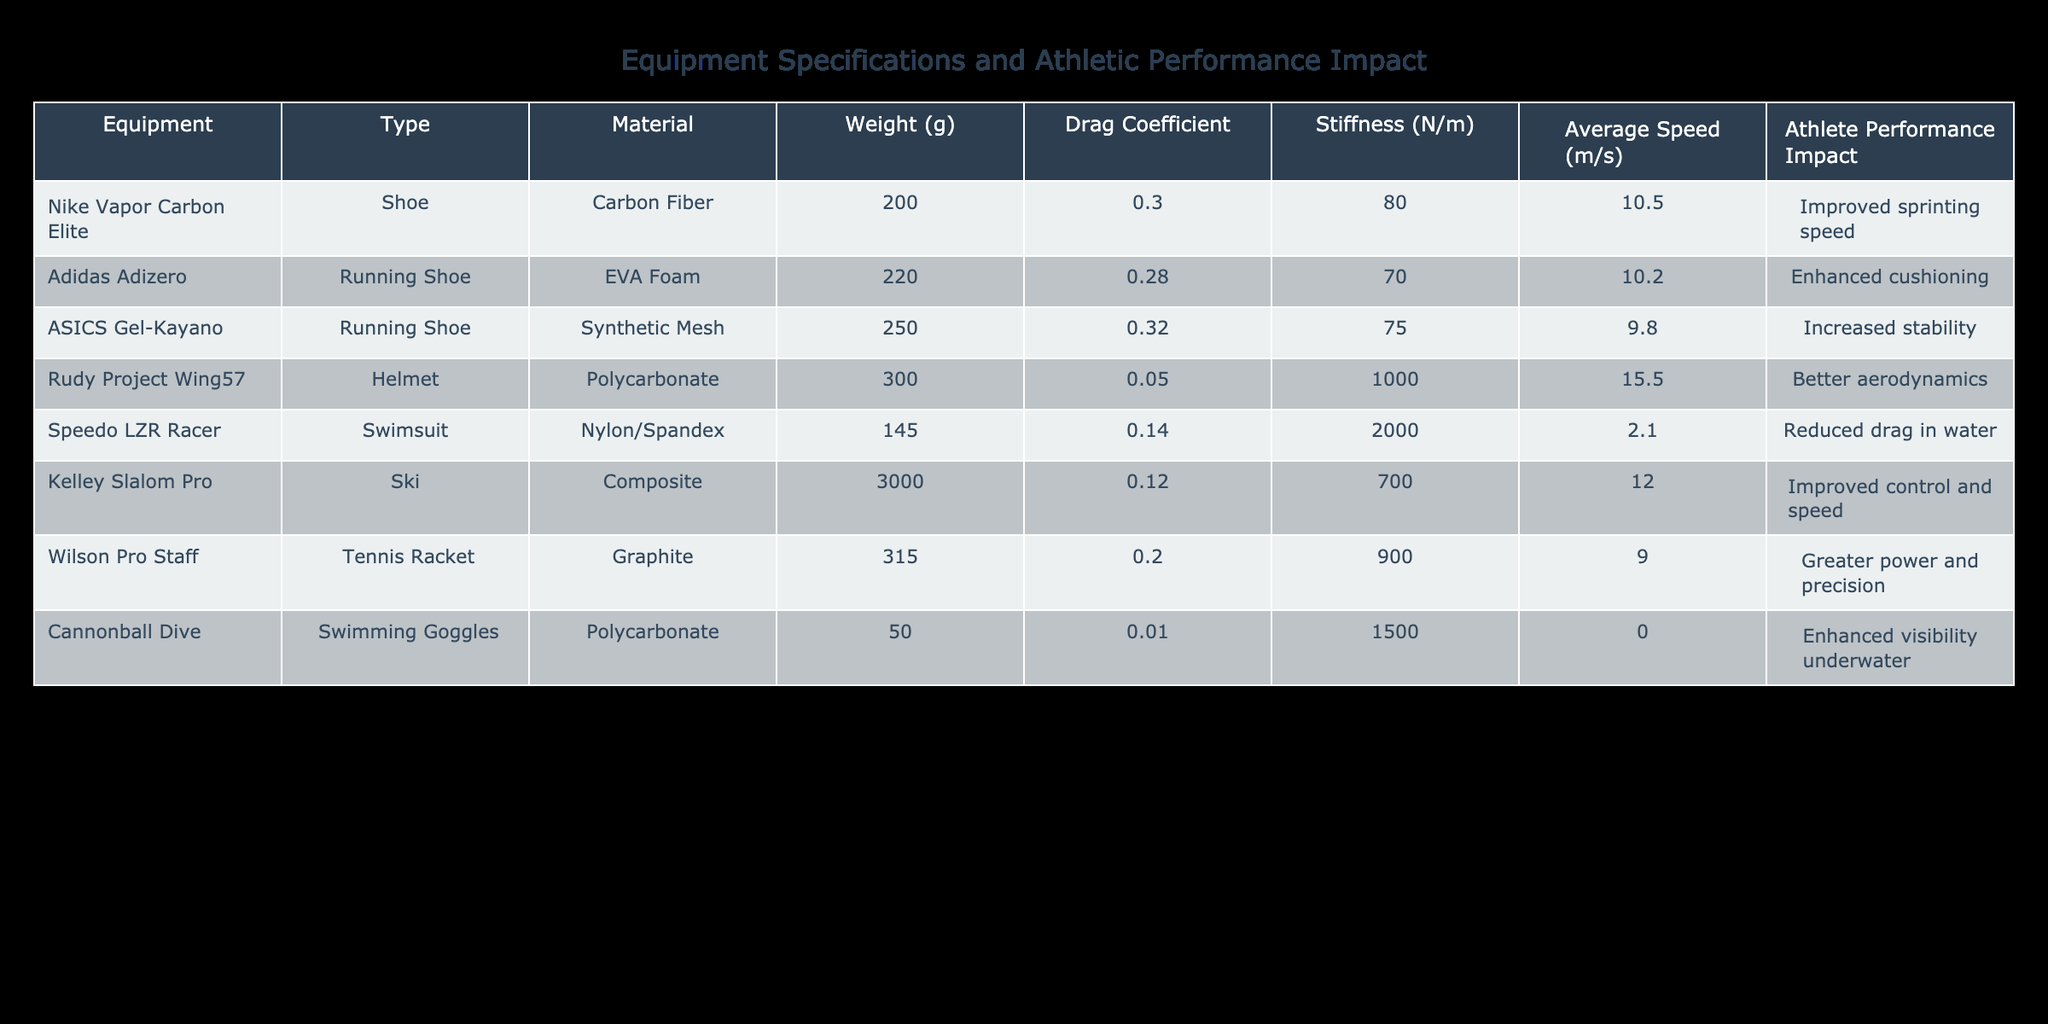What is the drag coefficient of the Nike Vapor Carbon Elite shoe? The table shows that the drag coefficient for the Nike Vapor Carbon Elite shoe is listed under the "Drag Coefficient" column. Referring directly to the table entry for this shoe, the value is 0.30.
Answer: 0.30 Which equipment has the highest stiffness value? By examining the "Stiffness" column of the table, we can compare the stiffness values of all the listed equipment items. The Rudy Project Wing57 helmet shows a stiffness of 1000 N/m, which is higher than all others.
Answer: Rudy Project Wing57 Is the Speedo LZR Racer swimsuit lighter than the Nike Vapor Carbon Elite shoe? To answer this, we compare their weights listed in the "Weight (g)" column. The Speedo LZR Racer weighs 145 g, while the Nike Vapor Carbon Elite shoe weighs 200 g. Since 145 g is less than 200 g, the swimsuit is lighter.
Answer: Yes What is the average weight of all the equipment items listed? First, sum the weights: (200 + 220 + 250 + 300 + 145 + 3000 + 315 + 50) = 4180 g. There are 8 items, so the average weight = 4180 g / 8 = 522.5 g.
Answer: 522.5 g Does the material with the least drag coefficient correspond to the equipment that has improved control and speed? The material with the least drag coefficient is the Kelley Slalom Pro ski at 0.12. It claims to improve control and speed. To determine if this statement is true, we note that "Improved control and speed" is indeed noted for Kelley Slalom Pro, thus confirming the relationship.
Answer: Yes Which running shoe has the highest average speed? We can directly compare the "Average Speed (m/s)" column for the running shoes. The Nike Vapor Carbon Elite has an average speed of 10.5 m/s, while Adidas Adizero and ASICS Gel-Kayano have 10.2 m/s and 9.8 m/s, respectively. Therefore, the Nike Vapor Carbon Elite has the highest average speed.
Answer: Nike Vapor Carbon Elite If an athlete switches from the ASICS Gel-Kayano to the Adidas Adizero, how much can they expect to improve their average speed? The average speed of ASICS Gel-Kayano is 9.8 m/s and the Adidas Adizero is 10.2 m/s. To find the improvement, we compute the difference: 10.2 m/s - 9.8 m/s = 0.4 m/s.
Answer: 0.4 m/s How many types of equipment mentioned are designed specifically for land sports? Reviewing the "Type" column, we see that the Nike Vapor Carbon Elite, Adidas Adizero, ASICS Gel-Kayano, and Wilson Pro Staff are all designed for land sports (sprinting, running, and tennis). This results in a total of 4 items.
Answer: 4 